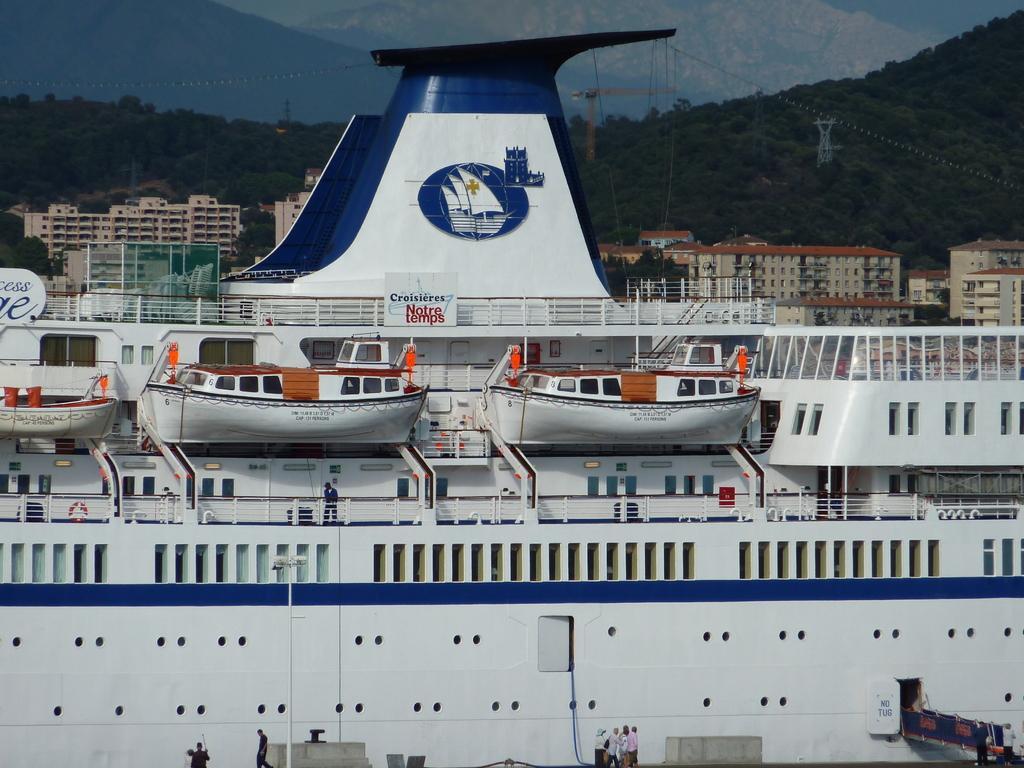Could you give a brief overview of what you see in this image? In this image we can see a big ship where we can see a few small boats and people walking here. In the background, we can see buildings, trees, crane, rope-way and the sky. 